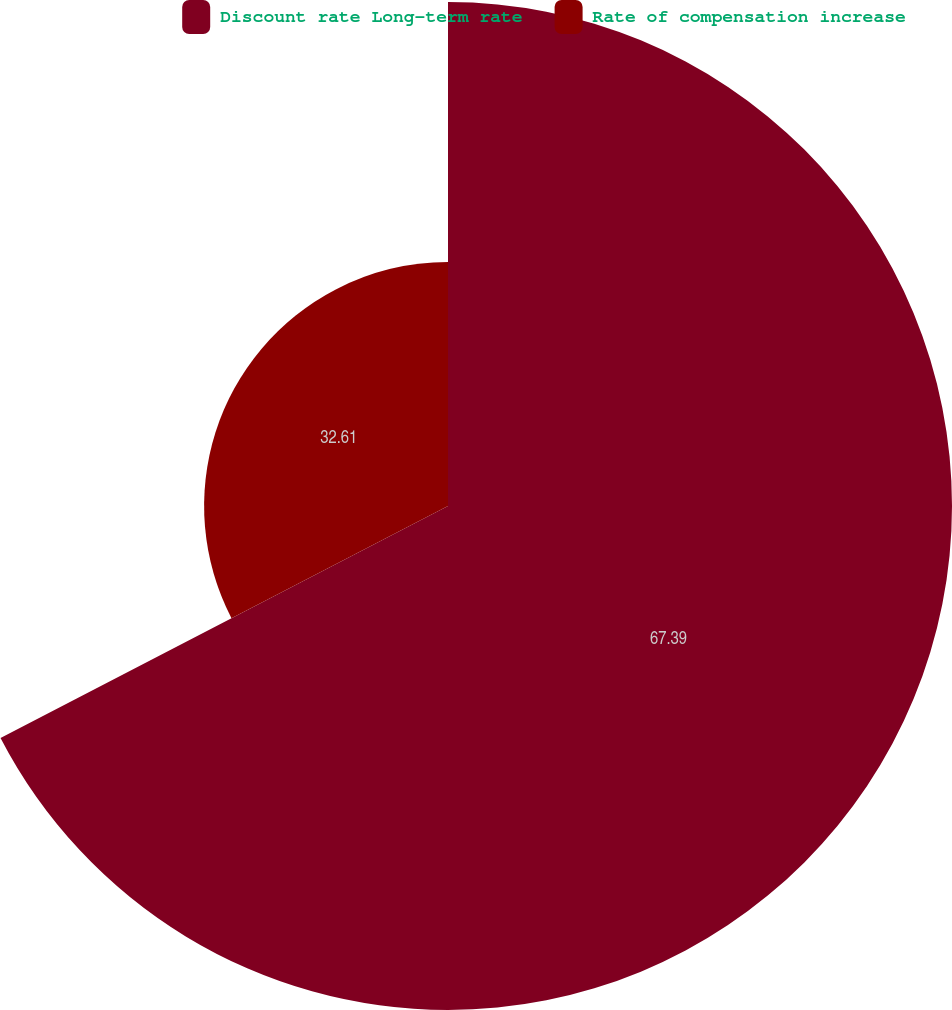Convert chart. <chart><loc_0><loc_0><loc_500><loc_500><pie_chart><fcel>Discount rate Long-term rate<fcel>Rate of compensation increase<nl><fcel>67.39%<fcel>32.61%<nl></chart> 